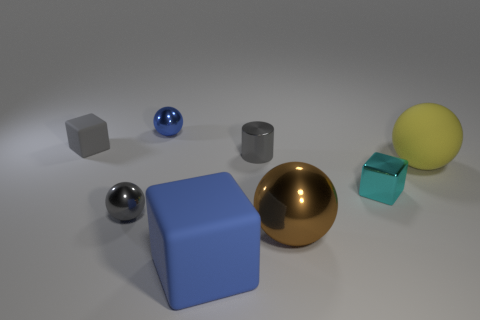Add 2 big yellow spheres. How many objects exist? 10 Subtract all cubes. How many objects are left? 5 Subtract all small gray balls. Subtract all yellow rubber blocks. How many objects are left? 7 Add 3 gray blocks. How many gray blocks are left? 4 Add 8 small green spheres. How many small green spheres exist? 8 Subtract 1 blue spheres. How many objects are left? 7 